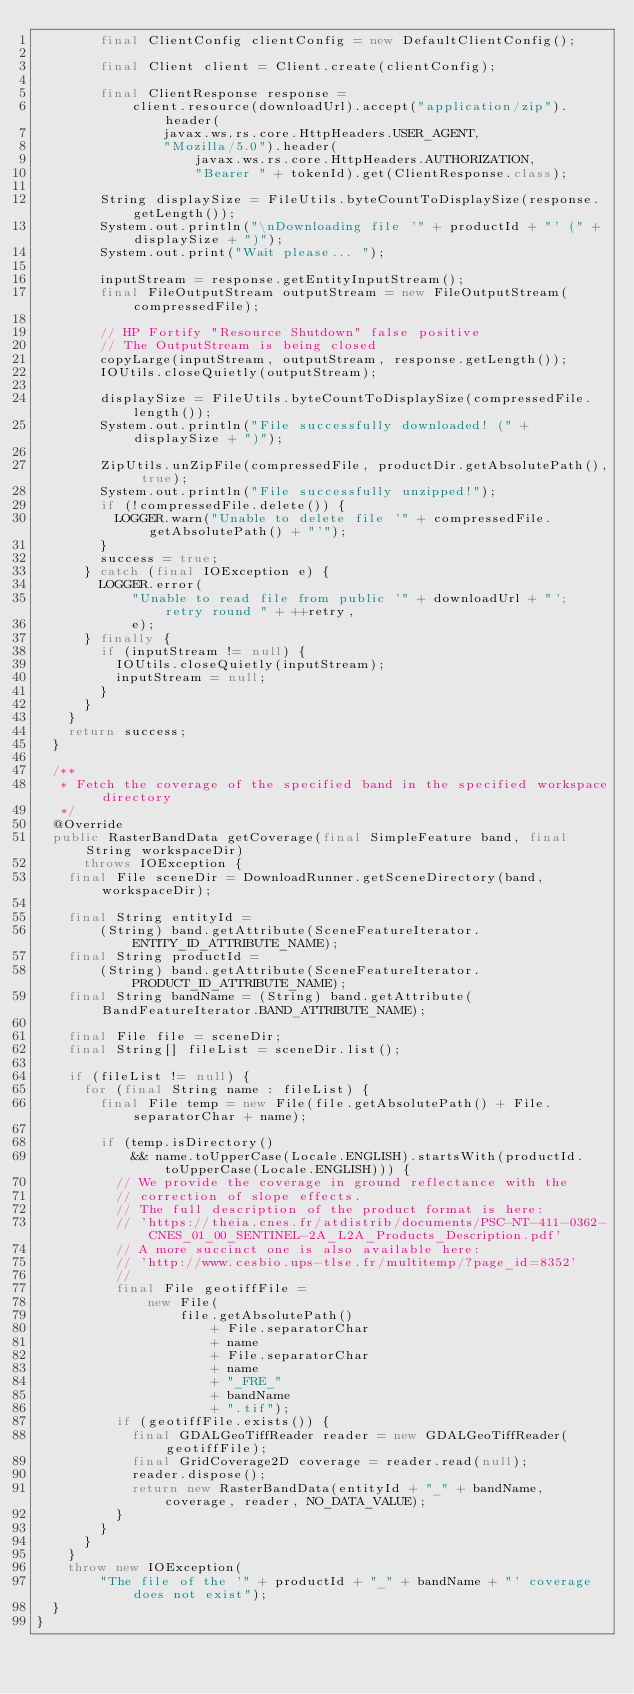Convert code to text. <code><loc_0><loc_0><loc_500><loc_500><_Java_>        final ClientConfig clientConfig = new DefaultClientConfig();

        final Client client = Client.create(clientConfig);

        final ClientResponse response =
            client.resource(downloadUrl).accept("application/zip").header(
                javax.ws.rs.core.HttpHeaders.USER_AGENT,
                "Mozilla/5.0").header(
                    javax.ws.rs.core.HttpHeaders.AUTHORIZATION,
                    "Bearer " + tokenId).get(ClientResponse.class);

        String displaySize = FileUtils.byteCountToDisplaySize(response.getLength());
        System.out.println("\nDownloading file '" + productId + "' (" + displaySize + ")");
        System.out.print("Wait please... ");

        inputStream = response.getEntityInputStream();
        final FileOutputStream outputStream = new FileOutputStream(compressedFile);

        // HP Fortify "Resource Shutdown" false positive
        // The OutputStream is being closed
        copyLarge(inputStream, outputStream, response.getLength());
        IOUtils.closeQuietly(outputStream);

        displaySize = FileUtils.byteCountToDisplaySize(compressedFile.length());
        System.out.println("File successfully downloaded! (" + displaySize + ")");

        ZipUtils.unZipFile(compressedFile, productDir.getAbsolutePath(), true);
        System.out.println("File successfully unzipped!");
        if (!compressedFile.delete()) {
          LOGGER.warn("Unable to delete file '" + compressedFile.getAbsolutePath() + "'");
        }
        success = true;
      } catch (final IOException e) {
        LOGGER.error(
            "Unable to read file from public '" + downloadUrl + "'; retry round " + ++retry,
            e);
      } finally {
        if (inputStream != null) {
          IOUtils.closeQuietly(inputStream);
          inputStream = null;
        }
      }
    }
    return success;
  }

  /**
   * Fetch the coverage of the specified band in the specified workspace directory
   */
  @Override
  public RasterBandData getCoverage(final SimpleFeature band, final String workspaceDir)
      throws IOException {
    final File sceneDir = DownloadRunner.getSceneDirectory(band, workspaceDir);

    final String entityId =
        (String) band.getAttribute(SceneFeatureIterator.ENTITY_ID_ATTRIBUTE_NAME);
    final String productId =
        (String) band.getAttribute(SceneFeatureIterator.PRODUCT_ID_ATTRIBUTE_NAME);
    final String bandName = (String) band.getAttribute(BandFeatureIterator.BAND_ATTRIBUTE_NAME);

    final File file = sceneDir;
    final String[] fileList = sceneDir.list();

    if (fileList != null) {
      for (final String name : fileList) {
        final File temp = new File(file.getAbsolutePath() + File.separatorChar + name);

        if (temp.isDirectory()
            && name.toUpperCase(Locale.ENGLISH).startsWith(productId.toUpperCase(Locale.ENGLISH))) {
          // We provide the coverage in ground reflectance with the
          // correction of slope effects.
          // The full description of the product format is here:
          // 'https://theia.cnes.fr/atdistrib/documents/PSC-NT-411-0362-CNES_01_00_SENTINEL-2A_L2A_Products_Description.pdf'
          // A more succinct one is also available here:
          // 'http://www.cesbio.ups-tlse.fr/multitemp/?page_id=8352'
          //
          final File geotiffFile =
              new File(
                  file.getAbsolutePath()
                      + File.separatorChar
                      + name
                      + File.separatorChar
                      + name
                      + "_FRE_"
                      + bandName
                      + ".tif");
          if (geotiffFile.exists()) {
            final GDALGeoTiffReader reader = new GDALGeoTiffReader(geotiffFile);
            final GridCoverage2D coverage = reader.read(null);
            reader.dispose();
            return new RasterBandData(entityId + "_" + bandName, coverage, reader, NO_DATA_VALUE);
          }
        }
      }
    }
    throw new IOException(
        "The file of the '" + productId + "_" + bandName + "' coverage does not exist");
  }
}
</code> 